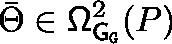<formula> <loc_0><loc_0><loc_500><loc_500>\bar { \Theta } \in \Omega _ { { G } _ { G } } ^ { 2 } ( P )</formula> 